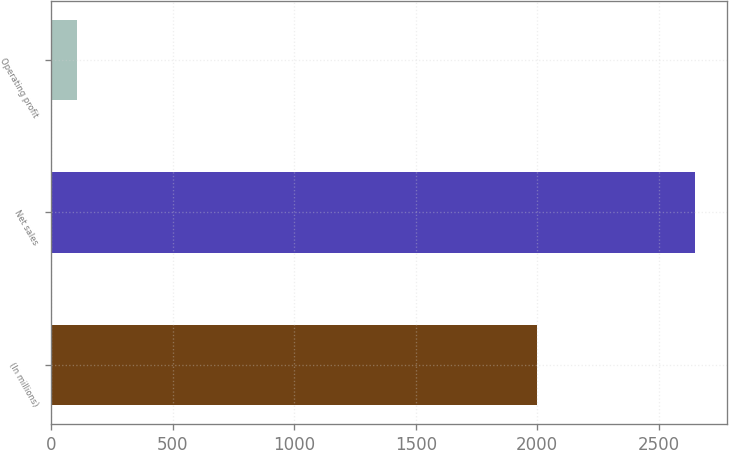<chart> <loc_0><loc_0><loc_500><loc_500><bar_chart><fcel>(In millions)<fcel>Net sales<fcel>Operating profit<nl><fcel>2000<fcel>2649<fcel>106<nl></chart> 